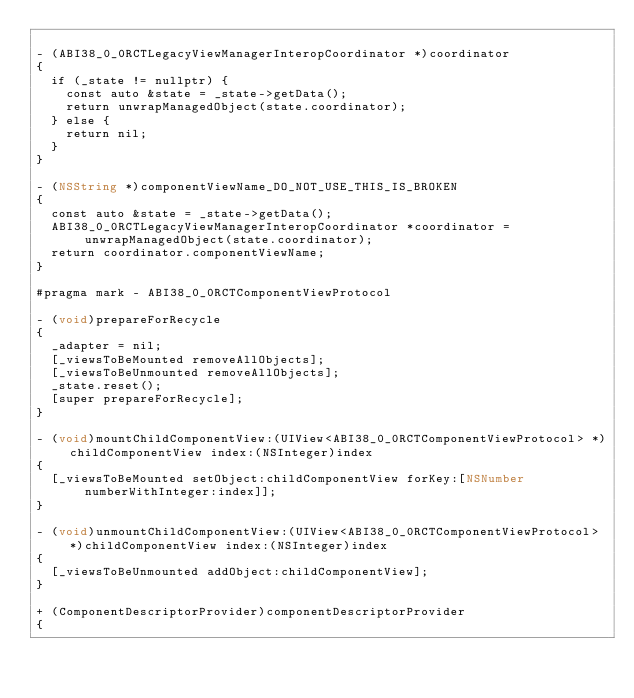<code> <loc_0><loc_0><loc_500><loc_500><_ObjectiveC_>
- (ABI38_0_0RCTLegacyViewManagerInteropCoordinator *)coordinator
{
  if (_state != nullptr) {
    const auto &state = _state->getData();
    return unwrapManagedObject(state.coordinator);
  } else {
    return nil;
  }
}

- (NSString *)componentViewName_DO_NOT_USE_THIS_IS_BROKEN
{
  const auto &state = _state->getData();
  ABI38_0_0RCTLegacyViewManagerInteropCoordinator *coordinator = unwrapManagedObject(state.coordinator);
  return coordinator.componentViewName;
}

#pragma mark - ABI38_0_0RCTComponentViewProtocol

- (void)prepareForRecycle
{
  _adapter = nil;
  [_viewsToBeMounted removeAllObjects];
  [_viewsToBeUnmounted removeAllObjects];
  _state.reset();
  [super prepareForRecycle];
}

- (void)mountChildComponentView:(UIView<ABI38_0_0RCTComponentViewProtocol> *)childComponentView index:(NSInteger)index
{
  [_viewsToBeMounted setObject:childComponentView forKey:[NSNumber numberWithInteger:index]];
}

- (void)unmountChildComponentView:(UIView<ABI38_0_0RCTComponentViewProtocol> *)childComponentView index:(NSInteger)index
{
  [_viewsToBeUnmounted addObject:childComponentView];
}

+ (ComponentDescriptorProvider)componentDescriptorProvider
{</code> 